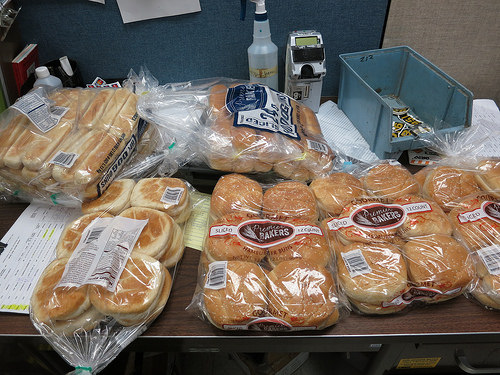<image>
Can you confirm if the hotdog rolls is next to the table? Yes. The hotdog rolls is positioned adjacent to the table, located nearby in the same general area. 